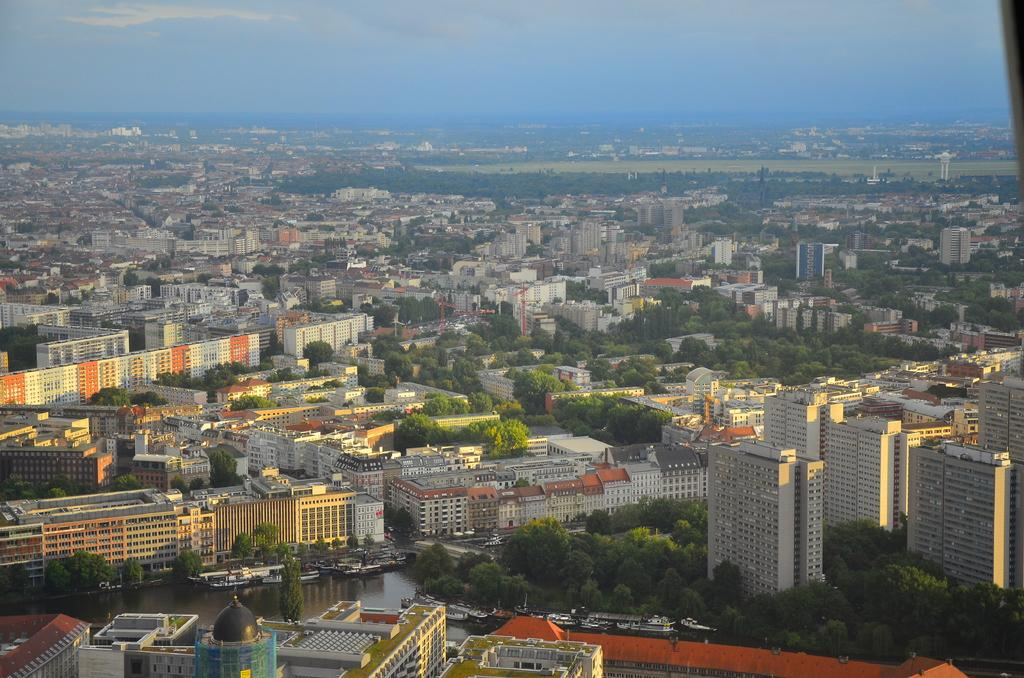What type of structures can be seen in the image? There are many buildings in the image. What type of vegetation is present in the image? There are trees in the image. What natural element is visible in the image? There is water visible in the image. What part of the natural environment is visible in the image? The sky is visible in the image. How many beds can be seen in the image? There are no beds present in the image. Is there a mountain visible in the image? There is no mountain visible in the image. 